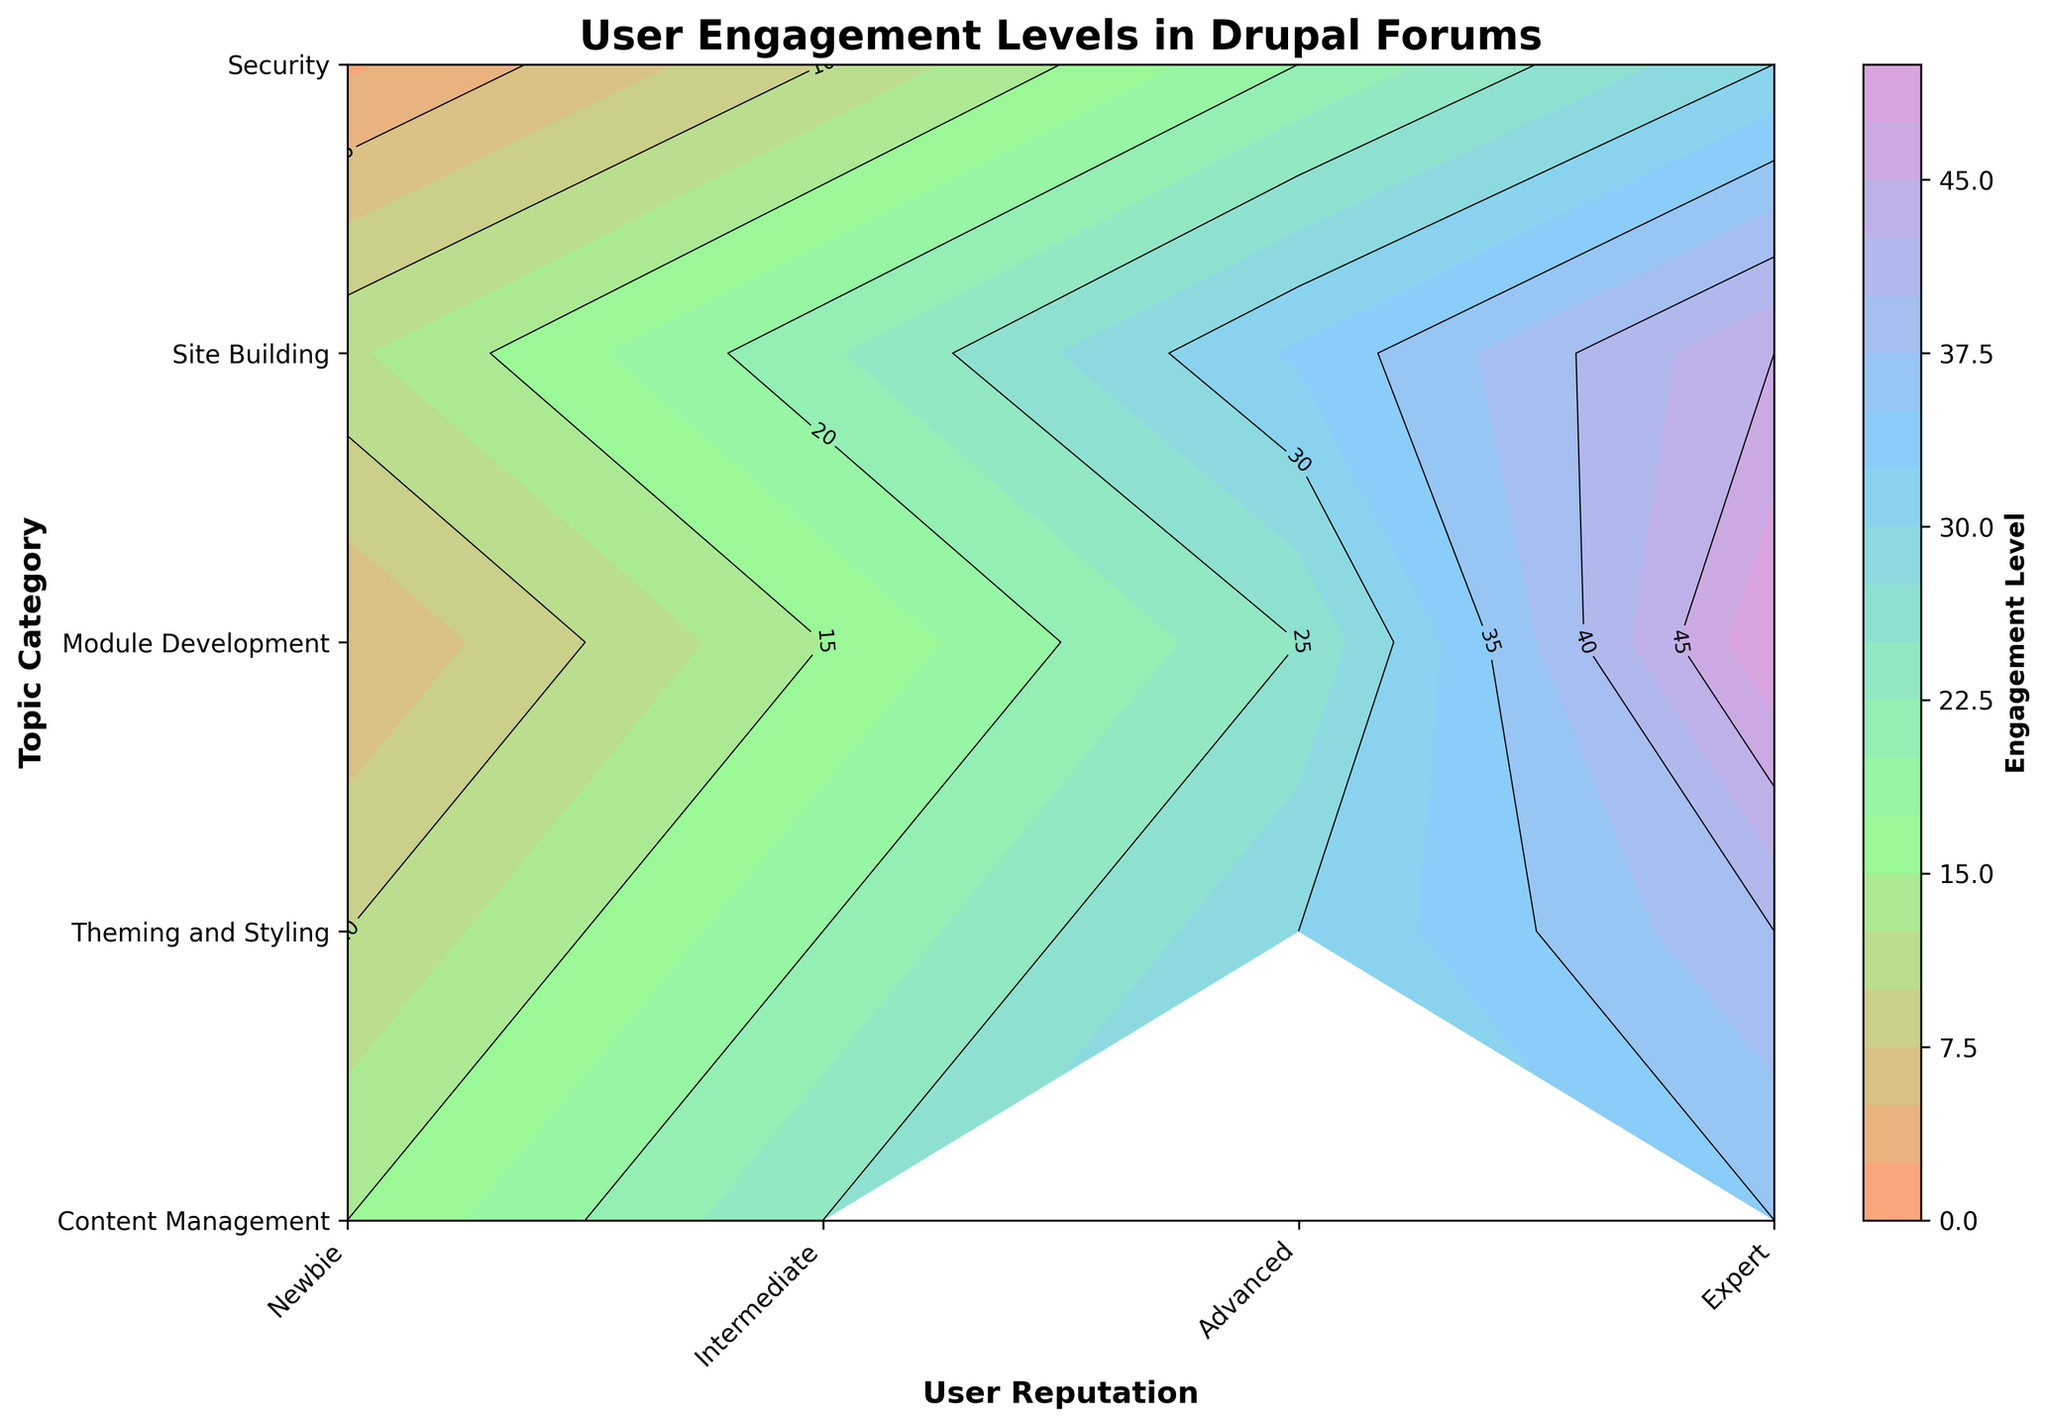What is the title of the figure? The title is at the top of the plot, typically used to describe the main subject. The title here reads "User Engagement Levels in Drupal Forums".
Answer: User Engagement Levels in Drupal Forums Which topic category shows the highest engagement level for Expert users? By looking for the highest contour value in the Expert column, the highest engagement for Expert users in the plot is in the "Module Development" category.
Answer: Module Development How does the engagement level compare between Intermediate and Expert users for Site Building? Locate the Site Building row and compare the values under Intermediate and Expert columns: Intermediate has an engagement level of 22, while Expert has 45.
Answer: Expert users have a higher engagement level What is the engagement level difference between Advanced users in Theming and Styling and Security? Find the engagement levels for Advanced users in both categories: Theming and Styling is 30, and Security is 20. The difference is 30 - 20.
Answer: 10 What user reputation level shows the lowest engagement in Security topics? Look at the engagement values for Security across all user reputations and find the minimum. The lowest value is for Newbie, which is 2.
Answer: Newbie Which category has the lowest engagement level for Newbie users? Look at the Newbie column and compare the values across different categories. The lowest engagement level for Newbie users is in the Security category, which is 2.
Answer: Security Identify two topic categories where Intermediate users have higher engagement levels compared to Newbies. Compare Intermediate and Newbie values for each category: Content Management (25 vs 15), Theming and Styling (20 vs 10), Module Development (15 vs 5), Site Building (22 vs 12), Security (10 vs 2). All categories show higher engagement for Intermediate users compared to Newbies. Pick two: Content Management and Theming and Styling.
Answer: Content Management and Theming and Styling Does any category show a decreasing trend in engagement level as user reputation increases? Examine each row to see if the engagement levels decrease as moving from Newbie to Expert. None of the categories show a decreasing trend; all have increasing engagement levels.
Answer: No What is the average engagement level of Expert users across all topics? Sum the engagement levels for Expert users in all categories: Content Management (35), Theming and Styling (40), Module Development (50), Site Building (45), Security (30). The sum is 35 + 40 + 50 + 45 + 30 = 200. There are 5 categories, so average = 200/5.
Answer: 40 